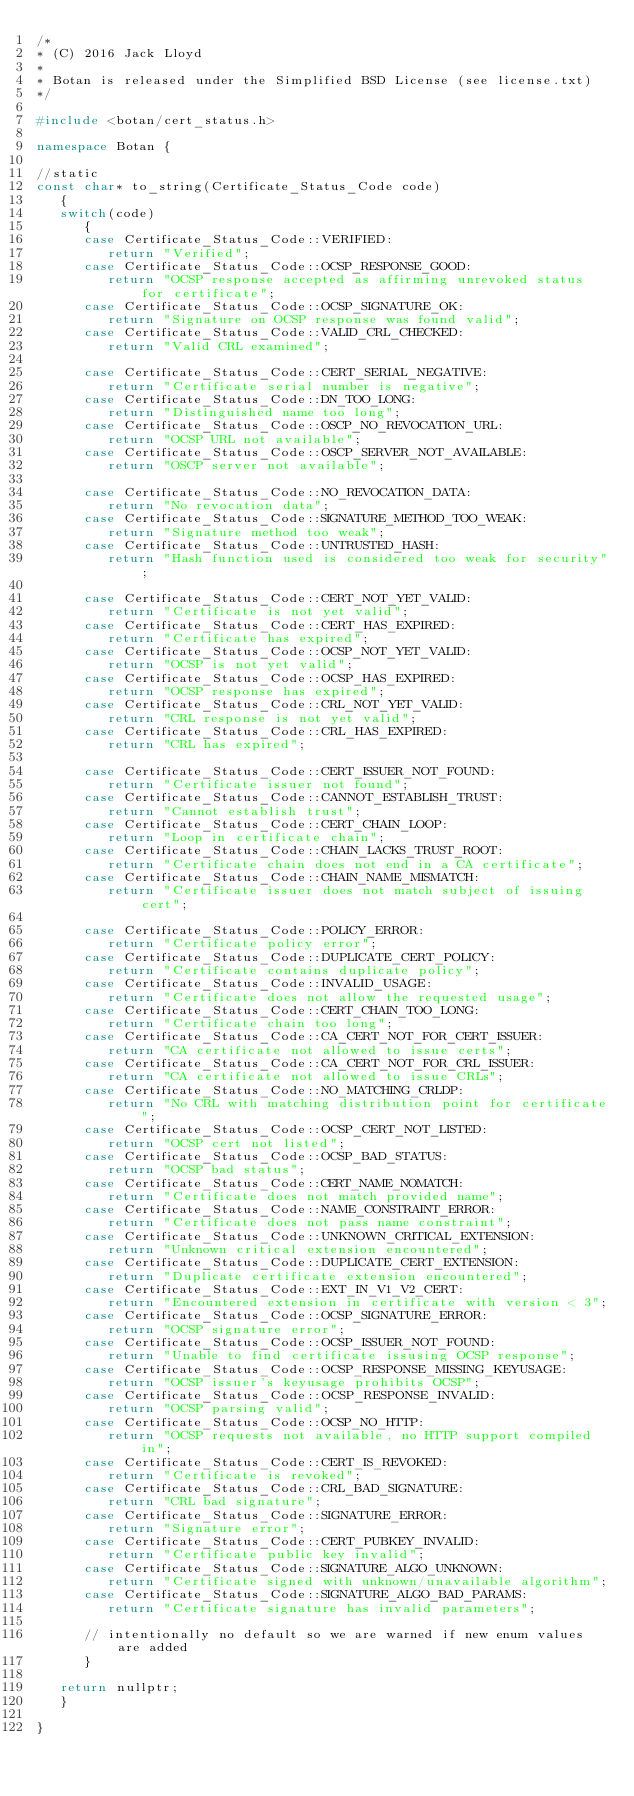<code> <loc_0><loc_0><loc_500><loc_500><_C++_>/*
* (C) 2016 Jack Lloyd
*
* Botan is released under the Simplified BSD License (see license.txt)
*/

#include <botan/cert_status.h>

namespace Botan {

//static
const char* to_string(Certificate_Status_Code code)
   {
   switch(code)
      {
      case Certificate_Status_Code::VERIFIED:
         return "Verified";
      case Certificate_Status_Code::OCSP_RESPONSE_GOOD:
         return "OCSP response accepted as affirming unrevoked status for certificate";
      case Certificate_Status_Code::OCSP_SIGNATURE_OK:
         return "Signature on OCSP response was found valid";
      case Certificate_Status_Code::VALID_CRL_CHECKED:
         return "Valid CRL examined";

      case Certificate_Status_Code::CERT_SERIAL_NEGATIVE:
         return "Certificate serial number is negative";
      case Certificate_Status_Code::DN_TOO_LONG:
         return "Distinguished name too long";
      case Certificate_Status_Code::OSCP_NO_REVOCATION_URL:
         return "OCSP URL not available";
      case Certificate_Status_Code::OSCP_SERVER_NOT_AVAILABLE:
         return "OSCP server not available";

      case Certificate_Status_Code::NO_REVOCATION_DATA:
         return "No revocation data";
      case Certificate_Status_Code::SIGNATURE_METHOD_TOO_WEAK:
         return "Signature method too weak";
      case Certificate_Status_Code::UNTRUSTED_HASH:
         return "Hash function used is considered too weak for security";

      case Certificate_Status_Code::CERT_NOT_YET_VALID:
         return "Certificate is not yet valid";
      case Certificate_Status_Code::CERT_HAS_EXPIRED:
         return "Certificate has expired";
      case Certificate_Status_Code::OCSP_NOT_YET_VALID:
         return "OCSP is not yet valid";
      case Certificate_Status_Code::OCSP_HAS_EXPIRED:
         return "OCSP response has expired";
      case Certificate_Status_Code::CRL_NOT_YET_VALID:
         return "CRL response is not yet valid";
      case Certificate_Status_Code::CRL_HAS_EXPIRED:
         return "CRL has expired";

      case Certificate_Status_Code::CERT_ISSUER_NOT_FOUND:
         return "Certificate issuer not found";
      case Certificate_Status_Code::CANNOT_ESTABLISH_TRUST:
         return "Cannot establish trust";
      case Certificate_Status_Code::CERT_CHAIN_LOOP:
         return "Loop in certificate chain";
      case Certificate_Status_Code::CHAIN_LACKS_TRUST_ROOT:
         return "Certificate chain does not end in a CA certificate";
      case Certificate_Status_Code::CHAIN_NAME_MISMATCH:
         return "Certificate issuer does not match subject of issuing cert";

      case Certificate_Status_Code::POLICY_ERROR:
         return "Certificate policy error";
      case Certificate_Status_Code::DUPLICATE_CERT_POLICY:
         return "Certificate contains duplicate policy";
      case Certificate_Status_Code::INVALID_USAGE:
         return "Certificate does not allow the requested usage";
      case Certificate_Status_Code::CERT_CHAIN_TOO_LONG:
         return "Certificate chain too long";
      case Certificate_Status_Code::CA_CERT_NOT_FOR_CERT_ISSUER:
         return "CA certificate not allowed to issue certs";
      case Certificate_Status_Code::CA_CERT_NOT_FOR_CRL_ISSUER:
         return "CA certificate not allowed to issue CRLs";
      case Certificate_Status_Code::NO_MATCHING_CRLDP:
         return "No CRL with matching distribution point for certificate";
      case Certificate_Status_Code::OCSP_CERT_NOT_LISTED:
         return "OCSP cert not listed";
      case Certificate_Status_Code::OCSP_BAD_STATUS:
         return "OCSP bad status";
      case Certificate_Status_Code::CERT_NAME_NOMATCH:
         return "Certificate does not match provided name";
      case Certificate_Status_Code::NAME_CONSTRAINT_ERROR:
         return "Certificate does not pass name constraint";
      case Certificate_Status_Code::UNKNOWN_CRITICAL_EXTENSION:
         return "Unknown critical extension encountered";
      case Certificate_Status_Code::DUPLICATE_CERT_EXTENSION:
         return "Duplicate certificate extension encountered";
      case Certificate_Status_Code::EXT_IN_V1_V2_CERT:
         return "Encountered extension in certificate with version < 3";
      case Certificate_Status_Code::OCSP_SIGNATURE_ERROR:
         return "OCSP signature error";
      case Certificate_Status_Code::OCSP_ISSUER_NOT_FOUND:
         return "Unable to find certificate issusing OCSP response";
      case Certificate_Status_Code::OCSP_RESPONSE_MISSING_KEYUSAGE:
         return "OCSP issuer's keyusage prohibits OCSP";
      case Certificate_Status_Code::OCSP_RESPONSE_INVALID:
         return "OCSP parsing valid";
      case Certificate_Status_Code::OCSP_NO_HTTP:
         return "OCSP requests not available, no HTTP support compiled in";
      case Certificate_Status_Code::CERT_IS_REVOKED:
         return "Certificate is revoked";
      case Certificate_Status_Code::CRL_BAD_SIGNATURE:
         return "CRL bad signature";
      case Certificate_Status_Code::SIGNATURE_ERROR:
         return "Signature error";
      case Certificate_Status_Code::CERT_PUBKEY_INVALID:
         return "Certificate public key invalid";
      case Certificate_Status_Code::SIGNATURE_ALGO_UNKNOWN:
         return "Certificate signed with unknown/unavailable algorithm";
      case Certificate_Status_Code::SIGNATURE_ALGO_BAD_PARAMS:
         return "Certificate signature has invalid parameters";

      // intentionally no default so we are warned if new enum values are added
      }

   return nullptr;
   }

}
</code> 